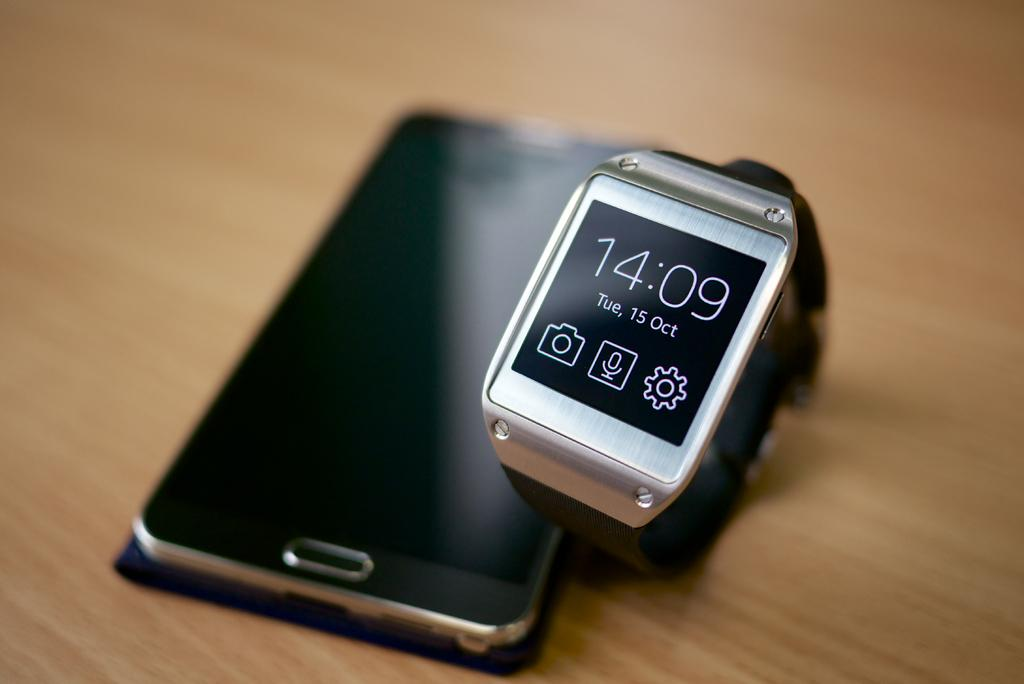<image>
Share a concise interpretation of the image provided. Phone next to a atch which says 14:09 on it. 